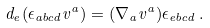<formula> <loc_0><loc_0><loc_500><loc_500>d _ { e } ( \epsilon _ { a b c d } v ^ { a } ) = ( \nabla _ { a } v ^ { a } ) \epsilon _ { e b c d } \, .</formula> 